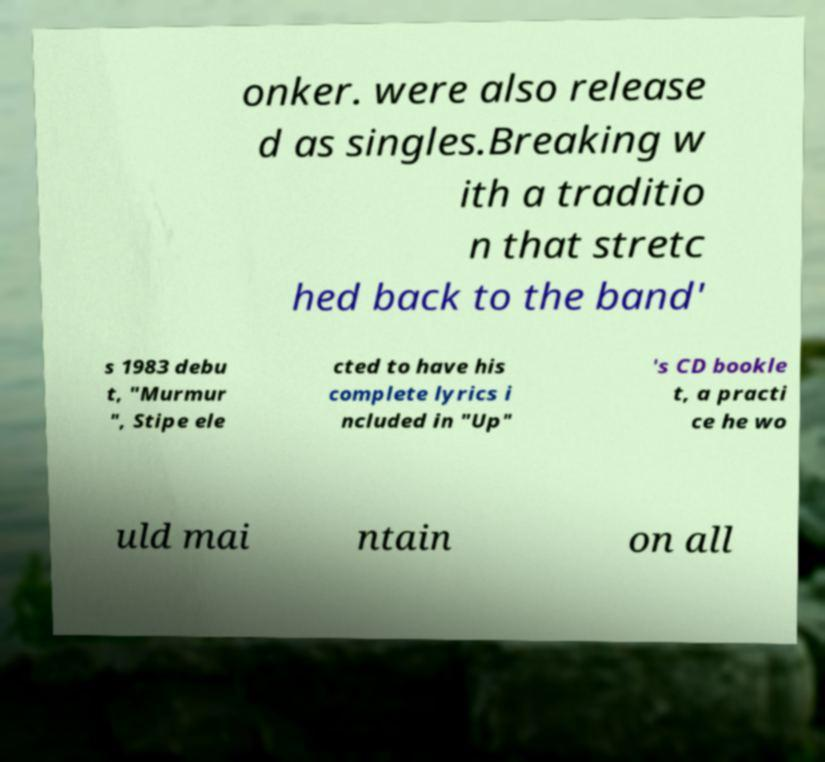Please identify and transcribe the text found in this image. onker. were also release d as singles.Breaking w ith a traditio n that stretc hed back to the band' s 1983 debu t, "Murmur ", Stipe ele cted to have his complete lyrics i ncluded in "Up" 's CD bookle t, a practi ce he wo uld mai ntain on all 